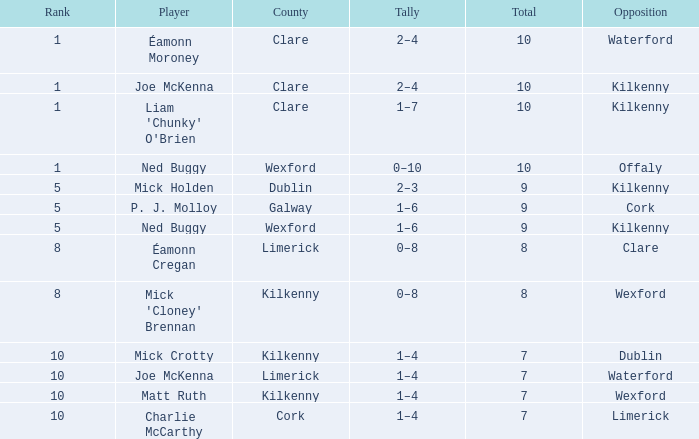Which Total has a County of kilkenny, and a Tally of 1–4, and a Rank larger than 10? None. 